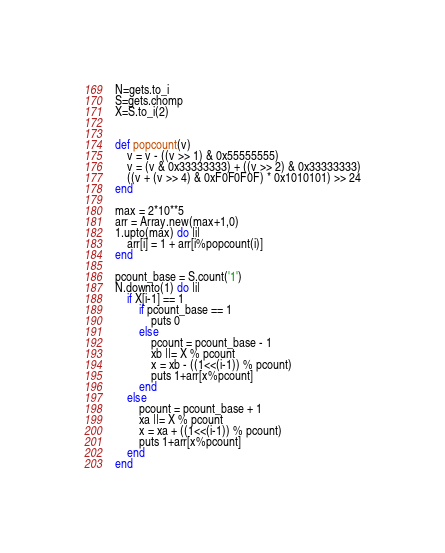<code> <loc_0><loc_0><loc_500><loc_500><_Ruby_>N=gets.to_i
S=gets.chomp
X=S.to_i(2)


def popcount(v)
    v = v - ((v >> 1) & 0x55555555)
    v = (v & 0x33333333) + ((v >> 2) & 0x33333333)
    ((v + (v >> 4) & 0xF0F0F0F) * 0x1010101) >> 24
end

max = 2*10**5
arr = Array.new(max+1,0)
1.upto(max) do |i|
    arr[i] = 1 + arr[i%popcount(i)]
end

pcount_base = S.count('1')
N.downto(1) do |i|
    if X[i-1] == 1
        if pcount_base == 1
            puts 0
        else
            pcount = pcount_base - 1
            xb ||= X % pcount
            x = xb - ((1<<(i-1)) % pcount)
            puts 1+arr[x%pcount]
        end
    else
        pcount = pcount_base + 1
        xa ||= X % pcount
        x = xa + ((1<<(i-1)) % pcount)
        puts 1+arr[x%pcount]
    end
end</code> 